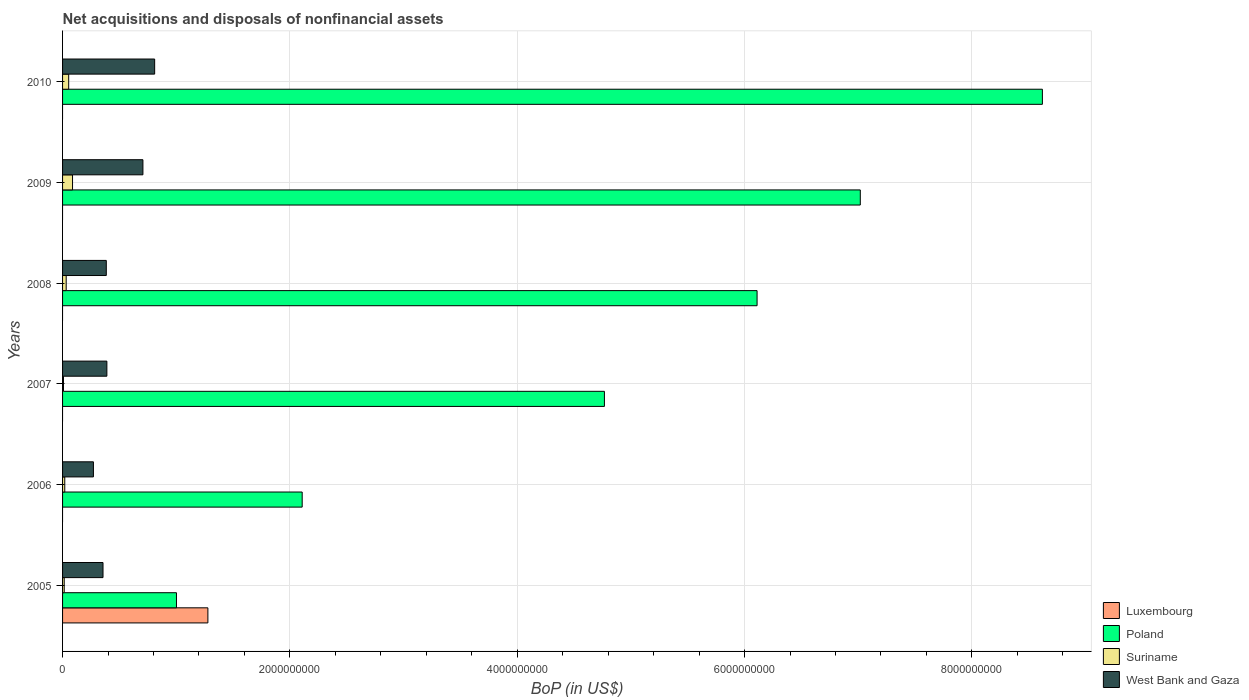Are the number of bars per tick equal to the number of legend labels?
Provide a short and direct response. No. In how many cases, is the number of bars for a given year not equal to the number of legend labels?
Give a very brief answer. 5. What is the Balance of Payments in Poland in 2008?
Offer a very short reply. 6.11e+09. Across all years, what is the maximum Balance of Payments in Poland?
Provide a succinct answer. 8.62e+09. In which year was the Balance of Payments in Luxembourg maximum?
Your answer should be compact. 2005. What is the total Balance of Payments in Luxembourg in the graph?
Provide a short and direct response. 1.28e+09. What is the difference between the Balance of Payments in Suriname in 2006 and that in 2007?
Offer a terse response. 1.12e+07. What is the difference between the Balance of Payments in West Bank and Gaza in 2005 and the Balance of Payments in Suriname in 2008?
Provide a succinct answer. 3.24e+08. What is the average Balance of Payments in Luxembourg per year?
Your answer should be very brief. 2.13e+08. In the year 2005, what is the difference between the Balance of Payments in Luxembourg and Balance of Payments in Poland?
Make the answer very short. 2.76e+08. In how many years, is the Balance of Payments in Poland greater than 1600000000 US$?
Provide a succinct answer. 5. What is the ratio of the Balance of Payments in Suriname in 2005 to that in 2010?
Ensure brevity in your answer.  0.27. What is the difference between the highest and the second highest Balance of Payments in Poland?
Your answer should be compact. 1.60e+09. What is the difference between the highest and the lowest Balance of Payments in Luxembourg?
Give a very brief answer. 1.28e+09. Is it the case that in every year, the sum of the Balance of Payments in Suriname and Balance of Payments in Luxembourg is greater than the sum of Balance of Payments in Poland and Balance of Payments in West Bank and Gaza?
Give a very brief answer. No. Are all the bars in the graph horizontal?
Your response must be concise. Yes. Does the graph contain any zero values?
Your response must be concise. Yes. Does the graph contain grids?
Your answer should be compact. Yes. How many legend labels are there?
Make the answer very short. 4. How are the legend labels stacked?
Provide a short and direct response. Vertical. What is the title of the graph?
Your answer should be very brief. Net acquisitions and disposals of nonfinancial assets. Does "Palau" appear as one of the legend labels in the graph?
Your answer should be very brief. No. What is the label or title of the X-axis?
Keep it short and to the point. BoP (in US$). What is the BoP (in US$) of Luxembourg in 2005?
Provide a succinct answer. 1.28e+09. What is the BoP (in US$) in Poland in 2005?
Your answer should be compact. 1.00e+09. What is the BoP (in US$) of Suriname in 2005?
Ensure brevity in your answer.  1.45e+07. What is the BoP (in US$) in West Bank and Gaza in 2005?
Give a very brief answer. 3.56e+08. What is the BoP (in US$) of Poland in 2006?
Make the answer very short. 2.11e+09. What is the BoP (in US$) of Suriname in 2006?
Provide a succinct answer. 1.93e+07. What is the BoP (in US$) of West Bank and Gaza in 2006?
Give a very brief answer. 2.71e+08. What is the BoP (in US$) in Luxembourg in 2007?
Provide a succinct answer. 0. What is the BoP (in US$) in Poland in 2007?
Provide a succinct answer. 4.77e+09. What is the BoP (in US$) of Suriname in 2007?
Provide a succinct answer. 8.10e+06. What is the BoP (in US$) of West Bank and Gaza in 2007?
Offer a very short reply. 3.90e+08. What is the BoP (in US$) of Poland in 2008?
Provide a short and direct response. 6.11e+09. What is the BoP (in US$) of Suriname in 2008?
Give a very brief answer. 3.19e+07. What is the BoP (in US$) in West Bank and Gaza in 2008?
Offer a terse response. 3.85e+08. What is the BoP (in US$) in Luxembourg in 2009?
Offer a very short reply. 0. What is the BoP (in US$) of Poland in 2009?
Offer a very short reply. 7.02e+09. What is the BoP (in US$) in Suriname in 2009?
Your answer should be very brief. 8.77e+07. What is the BoP (in US$) in West Bank and Gaza in 2009?
Provide a short and direct response. 7.07e+08. What is the BoP (in US$) in Poland in 2010?
Make the answer very short. 8.62e+09. What is the BoP (in US$) in Suriname in 2010?
Give a very brief answer. 5.39e+07. What is the BoP (in US$) in West Bank and Gaza in 2010?
Offer a terse response. 8.10e+08. Across all years, what is the maximum BoP (in US$) of Luxembourg?
Offer a very short reply. 1.28e+09. Across all years, what is the maximum BoP (in US$) of Poland?
Keep it short and to the point. 8.62e+09. Across all years, what is the maximum BoP (in US$) of Suriname?
Offer a very short reply. 8.77e+07. Across all years, what is the maximum BoP (in US$) in West Bank and Gaza?
Offer a very short reply. 8.10e+08. Across all years, what is the minimum BoP (in US$) of Poland?
Offer a very short reply. 1.00e+09. Across all years, what is the minimum BoP (in US$) of Suriname?
Provide a short and direct response. 8.10e+06. Across all years, what is the minimum BoP (in US$) in West Bank and Gaza?
Offer a very short reply. 2.71e+08. What is the total BoP (in US$) in Luxembourg in the graph?
Make the answer very short. 1.28e+09. What is the total BoP (in US$) in Poland in the graph?
Give a very brief answer. 2.96e+1. What is the total BoP (in US$) of Suriname in the graph?
Give a very brief answer. 2.15e+08. What is the total BoP (in US$) in West Bank and Gaza in the graph?
Offer a very short reply. 2.92e+09. What is the difference between the BoP (in US$) in Poland in 2005 and that in 2006?
Offer a terse response. -1.11e+09. What is the difference between the BoP (in US$) of Suriname in 2005 and that in 2006?
Provide a succinct answer. -4.80e+06. What is the difference between the BoP (in US$) of West Bank and Gaza in 2005 and that in 2006?
Provide a short and direct response. 8.44e+07. What is the difference between the BoP (in US$) in Poland in 2005 and that in 2007?
Provide a short and direct response. -3.76e+09. What is the difference between the BoP (in US$) in Suriname in 2005 and that in 2007?
Provide a short and direct response. 6.40e+06. What is the difference between the BoP (in US$) in West Bank and Gaza in 2005 and that in 2007?
Your answer should be compact. -3.40e+07. What is the difference between the BoP (in US$) of Poland in 2005 and that in 2008?
Offer a very short reply. -5.11e+09. What is the difference between the BoP (in US$) of Suriname in 2005 and that in 2008?
Your answer should be compact. -1.74e+07. What is the difference between the BoP (in US$) in West Bank and Gaza in 2005 and that in 2008?
Ensure brevity in your answer.  -2.89e+07. What is the difference between the BoP (in US$) of Poland in 2005 and that in 2009?
Offer a terse response. -6.02e+09. What is the difference between the BoP (in US$) in Suriname in 2005 and that in 2009?
Your answer should be compact. -7.32e+07. What is the difference between the BoP (in US$) of West Bank and Gaza in 2005 and that in 2009?
Make the answer very short. -3.51e+08. What is the difference between the BoP (in US$) of Poland in 2005 and that in 2010?
Give a very brief answer. -7.62e+09. What is the difference between the BoP (in US$) in Suriname in 2005 and that in 2010?
Offer a terse response. -3.94e+07. What is the difference between the BoP (in US$) in West Bank and Gaza in 2005 and that in 2010?
Provide a short and direct response. -4.54e+08. What is the difference between the BoP (in US$) in Poland in 2006 and that in 2007?
Provide a short and direct response. -2.66e+09. What is the difference between the BoP (in US$) of Suriname in 2006 and that in 2007?
Offer a terse response. 1.12e+07. What is the difference between the BoP (in US$) in West Bank and Gaza in 2006 and that in 2007?
Make the answer very short. -1.18e+08. What is the difference between the BoP (in US$) in Poland in 2006 and that in 2008?
Provide a short and direct response. -4.00e+09. What is the difference between the BoP (in US$) in Suriname in 2006 and that in 2008?
Your answer should be compact. -1.26e+07. What is the difference between the BoP (in US$) in West Bank and Gaza in 2006 and that in 2008?
Provide a short and direct response. -1.13e+08. What is the difference between the BoP (in US$) in Poland in 2006 and that in 2009?
Your answer should be very brief. -4.91e+09. What is the difference between the BoP (in US$) of Suriname in 2006 and that in 2009?
Keep it short and to the point. -6.84e+07. What is the difference between the BoP (in US$) of West Bank and Gaza in 2006 and that in 2009?
Your answer should be compact. -4.36e+08. What is the difference between the BoP (in US$) of Poland in 2006 and that in 2010?
Provide a short and direct response. -6.51e+09. What is the difference between the BoP (in US$) of Suriname in 2006 and that in 2010?
Offer a terse response. -3.46e+07. What is the difference between the BoP (in US$) in West Bank and Gaza in 2006 and that in 2010?
Provide a short and direct response. -5.39e+08. What is the difference between the BoP (in US$) in Poland in 2007 and that in 2008?
Keep it short and to the point. -1.34e+09. What is the difference between the BoP (in US$) of Suriname in 2007 and that in 2008?
Provide a short and direct response. -2.38e+07. What is the difference between the BoP (in US$) in West Bank and Gaza in 2007 and that in 2008?
Offer a very short reply. 5.09e+06. What is the difference between the BoP (in US$) of Poland in 2007 and that in 2009?
Offer a very short reply. -2.25e+09. What is the difference between the BoP (in US$) of Suriname in 2007 and that in 2009?
Your response must be concise. -7.96e+07. What is the difference between the BoP (in US$) of West Bank and Gaza in 2007 and that in 2009?
Offer a very short reply. -3.17e+08. What is the difference between the BoP (in US$) of Poland in 2007 and that in 2010?
Ensure brevity in your answer.  -3.85e+09. What is the difference between the BoP (in US$) of Suriname in 2007 and that in 2010?
Ensure brevity in your answer.  -4.58e+07. What is the difference between the BoP (in US$) of West Bank and Gaza in 2007 and that in 2010?
Offer a very short reply. -4.20e+08. What is the difference between the BoP (in US$) of Poland in 2008 and that in 2009?
Keep it short and to the point. -9.08e+08. What is the difference between the BoP (in US$) in Suriname in 2008 and that in 2009?
Make the answer very short. -5.58e+07. What is the difference between the BoP (in US$) in West Bank and Gaza in 2008 and that in 2009?
Your answer should be very brief. -3.22e+08. What is the difference between the BoP (in US$) in Poland in 2008 and that in 2010?
Provide a short and direct response. -2.51e+09. What is the difference between the BoP (in US$) of Suriname in 2008 and that in 2010?
Provide a short and direct response. -2.20e+07. What is the difference between the BoP (in US$) of West Bank and Gaza in 2008 and that in 2010?
Make the answer very short. -4.26e+08. What is the difference between the BoP (in US$) of Poland in 2009 and that in 2010?
Offer a very short reply. -1.60e+09. What is the difference between the BoP (in US$) of Suriname in 2009 and that in 2010?
Offer a terse response. 3.38e+07. What is the difference between the BoP (in US$) in West Bank and Gaza in 2009 and that in 2010?
Provide a succinct answer. -1.03e+08. What is the difference between the BoP (in US$) in Luxembourg in 2005 and the BoP (in US$) in Poland in 2006?
Provide a short and direct response. -8.30e+08. What is the difference between the BoP (in US$) of Luxembourg in 2005 and the BoP (in US$) of Suriname in 2006?
Ensure brevity in your answer.  1.26e+09. What is the difference between the BoP (in US$) in Luxembourg in 2005 and the BoP (in US$) in West Bank and Gaza in 2006?
Your answer should be very brief. 1.01e+09. What is the difference between the BoP (in US$) of Poland in 2005 and the BoP (in US$) of Suriname in 2006?
Offer a terse response. 9.83e+08. What is the difference between the BoP (in US$) in Poland in 2005 and the BoP (in US$) in West Bank and Gaza in 2006?
Provide a short and direct response. 7.31e+08. What is the difference between the BoP (in US$) of Suriname in 2005 and the BoP (in US$) of West Bank and Gaza in 2006?
Keep it short and to the point. -2.57e+08. What is the difference between the BoP (in US$) of Luxembourg in 2005 and the BoP (in US$) of Poland in 2007?
Offer a terse response. -3.49e+09. What is the difference between the BoP (in US$) in Luxembourg in 2005 and the BoP (in US$) in Suriname in 2007?
Your response must be concise. 1.27e+09. What is the difference between the BoP (in US$) of Luxembourg in 2005 and the BoP (in US$) of West Bank and Gaza in 2007?
Make the answer very short. 8.89e+08. What is the difference between the BoP (in US$) in Poland in 2005 and the BoP (in US$) in Suriname in 2007?
Offer a terse response. 9.94e+08. What is the difference between the BoP (in US$) of Poland in 2005 and the BoP (in US$) of West Bank and Gaza in 2007?
Ensure brevity in your answer.  6.12e+08. What is the difference between the BoP (in US$) of Suriname in 2005 and the BoP (in US$) of West Bank and Gaza in 2007?
Keep it short and to the point. -3.75e+08. What is the difference between the BoP (in US$) in Luxembourg in 2005 and the BoP (in US$) in Poland in 2008?
Offer a very short reply. -4.83e+09. What is the difference between the BoP (in US$) of Luxembourg in 2005 and the BoP (in US$) of Suriname in 2008?
Give a very brief answer. 1.25e+09. What is the difference between the BoP (in US$) of Luxembourg in 2005 and the BoP (in US$) of West Bank and Gaza in 2008?
Provide a succinct answer. 8.94e+08. What is the difference between the BoP (in US$) of Poland in 2005 and the BoP (in US$) of Suriname in 2008?
Your answer should be very brief. 9.70e+08. What is the difference between the BoP (in US$) of Poland in 2005 and the BoP (in US$) of West Bank and Gaza in 2008?
Offer a terse response. 6.17e+08. What is the difference between the BoP (in US$) in Suriname in 2005 and the BoP (in US$) in West Bank and Gaza in 2008?
Provide a short and direct response. -3.70e+08. What is the difference between the BoP (in US$) in Luxembourg in 2005 and the BoP (in US$) in Poland in 2009?
Your response must be concise. -5.74e+09. What is the difference between the BoP (in US$) of Luxembourg in 2005 and the BoP (in US$) of Suriname in 2009?
Ensure brevity in your answer.  1.19e+09. What is the difference between the BoP (in US$) of Luxembourg in 2005 and the BoP (in US$) of West Bank and Gaza in 2009?
Provide a succinct answer. 5.71e+08. What is the difference between the BoP (in US$) in Poland in 2005 and the BoP (in US$) in Suriname in 2009?
Offer a terse response. 9.14e+08. What is the difference between the BoP (in US$) of Poland in 2005 and the BoP (in US$) of West Bank and Gaza in 2009?
Provide a succinct answer. 2.95e+08. What is the difference between the BoP (in US$) of Suriname in 2005 and the BoP (in US$) of West Bank and Gaza in 2009?
Offer a terse response. -6.92e+08. What is the difference between the BoP (in US$) of Luxembourg in 2005 and the BoP (in US$) of Poland in 2010?
Keep it short and to the point. -7.34e+09. What is the difference between the BoP (in US$) in Luxembourg in 2005 and the BoP (in US$) in Suriname in 2010?
Provide a short and direct response. 1.22e+09. What is the difference between the BoP (in US$) of Luxembourg in 2005 and the BoP (in US$) of West Bank and Gaza in 2010?
Provide a succinct answer. 4.68e+08. What is the difference between the BoP (in US$) of Poland in 2005 and the BoP (in US$) of Suriname in 2010?
Give a very brief answer. 9.48e+08. What is the difference between the BoP (in US$) in Poland in 2005 and the BoP (in US$) in West Bank and Gaza in 2010?
Provide a short and direct response. 1.92e+08. What is the difference between the BoP (in US$) of Suriname in 2005 and the BoP (in US$) of West Bank and Gaza in 2010?
Make the answer very short. -7.96e+08. What is the difference between the BoP (in US$) in Poland in 2006 and the BoP (in US$) in Suriname in 2007?
Offer a terse response. 2.10e+09. What is the difference between the BoP (in US$) in Poland in 2006 and the BoP (in US$) in West Bank and Gaza in 2007?
Provide a short and direct response. 1.72e+09. What is the difference between the BoP (in US$) of Suriname in 2006 and the BoP (in US$) of West Bank and Gaza in 2007?
Offer a terse response. -3.70e+08. What is the difference between the BoP (in US$) in Poland in 2006 and the BoP (in US$) in Suriname in 2008?
Keep it short and to the point. 2.08e+09. What is the difference between the BoP (in US$) of Poland in 2006 and the BoP (in US$) of West Bank and Gaza in 2008?
Your answer should be compact. 1.72e+09. What is the difference between the BoP (in US$) in Suriname in 2006 and the BoP (in US$) in West Bank and Gaza in 2008?
Provide a succinct answer. -3.65e+08. What is the difference between the BoP (in US$) in Poland in 2006 and the BoP (in US$) in Suriname in 2009?
Give a very brief answer. 2.02e+09. What is the difference between the BoP (in US$) in Poland in 2006 and the BoP (in US$) in West Bank and Gaza in 2009?
Give a very brief answer. 1.40e+09. What is the difference between the BoP (in US$) of Suriname in 2006 and the BoP (in US$) of West Bank and Gaza in 2009?
Provide a short and direct response. -6.88e+08. What is the difference between the BoP (in US$) of Poland in 2006 and the BoP (in US$) of Suriname in 2010?
Ensure brevity in your answer.  2.05e+09. What is the difference between the BoP (in US$) of Poland in 2006 and the BoP (in US$) of West Bank and Gaza in 2010?
Make the answer very short. 1.30e+09. What is the difference between the BoP (in US$) of Suriname in 2006 and the BoP (in US$) of West Bank and Gaza in 2010?
Provide a succinct answer. -7.91e+08. What is the difference between the BoP (in US$) in Poland in 2007 and the BoP (in US$) in Suriname in 2008?
Offer a terse response. 4.74e+09. What is the difference between the BoP (in US$) in Poland in 2007 and the BoP (in US$) in West Bank and Gaza in 2008?
Your answer should be very brief. 4.38e+09. What is the difference between the BoP (in US$) of Suriname in 2007 and the BoP (in US$) of West Bank and Gaza in 2008?
Your answer should be compact. -3.77e+08. What is the difference between the BoP (in US$) in Poland in 2007 and the BoP (in US$) in Suriname in 2009?
Your answer should be compact. 4.68e+09. What is the difference between the BoP (in US$) in Poland in 2007 and the BoP (in US$) in West Bank and Gaza in 2009?
Your answer should be very brief. 4.06e+09. What is the difference between the BoP (in US$) of Suriname in 2007 and the BoP (in US$) of West Bank and Gaza in 2009?
Keep it short and to the point. -6.99e+08. What is the difference between the BoP (in US$) in Poland in 2007 and the BoP (in US$) in Suriname in 2010?
Your answer should be very brief. 4.71e+09. What is the difference between the BoP (in US$) of Poland in 2007 and the BoP (in US$) of West Bank and Gaza in 2010?
Provide a succinct answer. 3.96e+09. What is the difference between the BoP (in US$) in Suriname in 2007 and the BoP (in US$) in West Bank and Gaza in 2010?
Make the answer very short. -8.02e+08. What is the difference between the BoP (in US$) of Poland in 2008 and the BoP (in US$) of Suriname in 2009?
Your response must be concise. 6.02e+09. What is the difference between the BoP (in US$) of Poland in 2008 and the BoP (in US$) of West Bank and Gaza in 2009?
Your answer should be compact. 5.40e+09. What is the difference between the BoP (in US$) of Suriname in 2008 and the BoP (in US$) of West Bank and Gaza in 2009?
Give a very brief answer. -6.75e+08. What is the difference between the BoP (in US$) in Poland in 2008 and the BoP (in US$) in Suriname in 2010?
Make the answer very short. 6.06e+09. What is the difference between the BoP (in US$) in Poland in 2008 and the BoP (in US$) in West Bank and Gaza in 2010?
Ensure brevity in your answer.  5.30e+09. What is the difference between the BoP (in US$) of Suriname in 2008 and the BoP (in US$) of West Bank and Gaza in 2010?
Offer a terse response. -7.78e+08. What is the difference between the BoP (in US$) in Poland in 2009 and the BoP (in US$) in Suriname in 2010?
Your response must be concise. 6.96e+09. What is the difference between the BoP (in US$) in Poland in 2009 and the BoP (in US$) in West Bank and Gaza in 2010?
Make the answer very short. 6.21e+09. What is the difference between the BoP (in US$) of Suriname in 2009 and the BoP (in US$) of West Bank and Gaza in 2010?
Your answer should be very brief. -7.22e+08. What is the average BoP (in US$) of Luxembourg per year?
Provide a succinct answer. 2.13e+08. What is the average BoP (in US$) of Poland per year?
Provide a short and direct response. 4.94e+09. What is the average BoP (in US$) of Suriname per year?
Your answer should be compact. 3.59e+07. What is the average BoP (in US$) in West Bank and Gaza per year?
Give a very brief answer. 4.86e+08. In the year 2005, what is the difference between the BoP (in US$) in Luxembourg and BoP (in US$) in Poland?
Your answer should be compact. 2.76e+08. In the year 2005, what is the difference between the BoP (in US$) in Luxembourg and BoP (in US$) in Suriname?
Provide a short and direct response. 1.26e+09. In the year 2005, what is the difference between the BoP (in US$) of Luxembourg and BoP (in US$) of West Bank and Gaza?
Ensure brevity in your answer.  9.23e+08. In the year 2005, what is the difference between the BoP (in US$) in Poland and BoP (in US$) in Suriname?
Your response must be concise. 9.88e+08. In the year 2005, what is the difference between the BoP (in US$) in Poland and BoP (in US$) in West Bank and Gaza?
Keep it short and to the point. 6.46e+08. In the year 2005, what is the difference between the BoP (in US$) in Suriname and BoP (in US$) in West Bank and Gaza?
Your response must be concise. -3.41e+08. In the year 2006, what is the difference between the BoP (in US$) in Poland and BoP (in US$) in Suriname?
Keep it short and to the point. 2.09e+09. In the year 2006, what is the difference between the BoP (in US$) in Poland and BoP (in US$) in West Bank and Gaza?
Keep it short and to the point. 1.84e+09. In the year 2006, what is the difference between the BoP (in US$) in Suriname and BoP (in US$) in West Bank and Gaza?
Your response must be concise. -2.52e+08. In the year 2007, what is the difference between the BoP (in US$) in Poland and BoP (in US$) in Suriname?
Provide a succinct answer. 4.76e+09. In the year 2007, what is the difference between the BoP (in US$) in Poland and BoP (in US$) in West Bank and Gaza?
Make the answer very short. 4.38e+09. In the year 2007, what is the difference between the BoP (in US$) of Suriname and BoP (in US$) of West Bank and Gaza?
Offer a terse response. -3.82e+08. In the year 2008, what is the difference between the BoP (in US$) of Poland and BoP (in US$) of Suriname?
Provide a short and direct response. 6.08e+09. In the year 2008, what is the difference between the BoP (in US$) of Poland and BoP (in US$) of West Bank and Gaza?
Your response must be concise. 5.73e+09. In the year 2008, what is the difference between the BoP (in US$) in Suriname and BoP (in US$) in West Bank and Gaza?
Your answer should be very brief. -3.53e+08. In the year 2009, what is the difference between the BoP (in US$) of Poland and BoP (in US$) of Suriname?
Keep it short and to the point. 6.93e+09. In the year 2009, what is the difference between the BoP (in US$) in Poland and BoP (in US$) in West Bank and Gaza?
Your answer should be compact. 6.31e+09. In the year 2009, what is the difference between the BoP (in US$) of Suriname and BoP (in US$) of West Bank and Gaza?
Ensure brevity in your answer.  -6.19e+08. In the year 2010, what is the difference between the BoP (in US$) of Poland and BoP (in US$) of Suriname?
Offer a terse response. 8.57e+09. In the year 2010, what is the difference between the BoP (in US$) in Poland and BoP (in US$) in West Bank and Gaza?
Your answer should be compact. 7.81e+09. In the year 2010, what is the difference between the BoP (in US$) of Suriname and BoP (in US$) of West Bank and Gaza?
Provide a short and direct response. -7.56e+08. What is the ratio of the BoP (in US$) of Poland in 2005 to that in 2006?
Provide a short and direct response. 0.48. What is the ratio of the BoP (in US$) of Suriname in 2005 to that in 2006?
Your answer should be compact. 0.75. What is the ratio of the BoP (in US$) of West Bank and Gaza in 2005 to that in 2006?
Offer a terse response. 1.31. What is the ratio of the BoP (in US$) of Poland in 2005 to that in 2007?
Your answer should be compact. 0.21. What is the ratio of the BoP (in US$) of Suriname in 2005 to that in 2007?
Your answer should be compact. 1.79. What is the ratio of the BoP (in US$) in West Bank and Gaza in 2005 to that in 2007?
Give a very brief answer. 0.91. What is the ratio of the BoP (in US$) in Poland in 2005 to that in 2008?
Ensure brevity in your answer.  0.16. What is the ratio of the BoP (in US$) in Suriname in 2005 to that in 2008?
Your answer should be compact. 0.45. What is the ratio of the BoP (in US$) in West Bank and Gaza in 2005 to that in 2008?
Ensure brevity in your answer.  0.92. What is the ratio of the BoP (in US$) of Poland in 2005 to that in 2009?
Provide a short and direct response. 0.14. What is the ratio of the BoP (in US$) in Suriname in 2005 to that in 2009?
Keep it short and to the point. 0.17. What is the ratio of the BoP (in US$) of West Bank and Gaza in 2005 to that in 2009?
Offer a very short reply. 0.5. What is the ratio of the BoP (in US$) in Poland in 2005 to that in 2010?
Your answer should be very brief. 0.12. What is the ratio of the BoP (in US$) of Suriname in 2005 to that in 2010?
Ensure brevity in your answer.  0.27. What is the ratio of the BoP (in US$) in West Bank and Gaza in 2005 to that in 2010?
Give a very brief answer. 0.44. What is the ratio of the BoP (in US$) of Poland in 2006 to that in 2007?
Give a very brief answer. 0.44. What is the ratio of the BoP (in US$) of Suriname in 2006 to that in 2007?
Keep it short and to the point. 2.38. What is the ratio of the BoP (in US$) in West Bank and Gaza in 2006 to that in 2007?
Your answer should be very brief. 0.7. What is the ratio of the BoP (in US$) of Poland in 2006 to that in 2008?
Make the answer very short. 0.34. What is the ratio of the BoP (in US$) of Suriname in 2006 to that in 2008?
Provide a succinct answer. 0.6. What is the ratio of the BoP (in US$) of West Bank and Gaza in 2006 to that in 2008?
Your answer should be very brief. 0.71. What is the ratio of the BoP (in US$) of Poland in 2006 to that in 2009?
Offer a very short reply. 0.3. What is the ratio of the BoP (in US$) in Suriname in 2006 to that in 2009?
Your answer should be very brief. 0.22. What is the ratio of the BoP (in US$) of West Bank and Gaza in 2006 to that in 2009?
Your response must be concise. 0.38. What is the ratio of the BoP (in US$) of Poland in 2006 to that in 2010?
Provide a succinct answer. 0.24. What is the ratio of the BoP (in US$) in Suriname in 2006 to that in 2010?
Give a very brief answer. 0.36. What is the ratio of the BoP (in US$) of West Bank and Gaza in 2006 to that in 2010?
Provide a short and direct response. 0.34. What is the ratio of the BoP (in US$) in Poland in 2007 to that in 2008?
Offer a very short reply. 0.78. What is the ratio of the BoP (in US$) in Suriname in 2007 to that in 2008?
Provide a short and direct response. 0.25. What is the ratio of the BoP (in US$) in West Bank and Gaza in 2007 to that in 2008?
Ensure brevity in your answer.  1.01. What is the ratio of the BoP (in US$) of Poland in 2007 to that in 2009?
Offer a very short reply. 0.68. What is the ratio of the BoP (in US$) in Suriname in 2007 to that in 2009?
Ensure brevity in your answer.  0.09. What is the ratio of the BoP (in US$) of West Bank and Gaza in 2007 to that in 2009?
Offer a terse response. 0.55. What is the ratio of the BoP (in US$) of Poland in 2007 to that in 2010?
Your answer should be very brief. 0.55. What is the ratio of the BoP (in US$) in Suriname in 2007 to that in 2010?
Your answer should be compact. 0.15. What is the ratio of the BoP (in US$) of West Bank and Gaza in 2007 to that in 2010?
Make the answer very short. 0.48. What is the ratio of the BoP (in US$) of Poland in 2008 to that in 2009?
Make the answer very short. 0.87. What is the ratio of the BoP (in US$) of Suriname in 2008 to that in 2009?
Offer a terse response. 0.36. What is the ratio of the BoP (in US$) in West Bank and Gaza in 2008 to that in 2009?
Offer a terse response. 0.54. What is the ratio of the BoP (in US$) of Poland in 2008 to that in 2010?
Provide a succinct answer. 0.71. What is the ratio of the BoP (in US$) in Suriname in 2008 to that in 2010?
Provide a succinct answer. 0.59. What is the ratio of the BoP (in US$) of West Bank and Gaza in 2008 to that in 2010?
Offer a terse response. 0.47. What is the ratio of the BoP (in US$) of Poland in 2009 to that in 2010?
Your response must be concise. 0.81. What is the ratio of the BoP (in US$) of Suriname in 2009 to that in 2010?
Make the answer very short. 1.63. What is the ratio of the BoP (in US$) in West Bank and Gaza in 2009 to that in 2010?
Provide a short and direct response. 0.87. What is the difference between the highest and the second highest BoP (in US$) of Poland?
Your response must be concise. 1.60e+09. What is the difference between the highest and the second highest BoP (in US$) of Suriname?
Provide a succinct answer. 3.38e+07. What is the difference between the highest and the second highest BoP (in US$) in West Bank and Gaza?
Provide a short and direct response. 1.03e+08. What is the difference between the highest and the lowest BoP (in US$) in Luxembourg?
Keep it short and to the point. 1.28e+09. What is the difference between the highest and the lowest BoP (in US$) of Poland?
Make the answer very short. 7.62e+09. What is the difference between the highest and the lowest BoP (in US$) of Suriname?
Your answer should be very brief. 7.96e+07. What is the difference between the highest and the lowest BoP (in US$) of West Bank and Gaza?
Provide a succinct answer. 5.39e+08. 